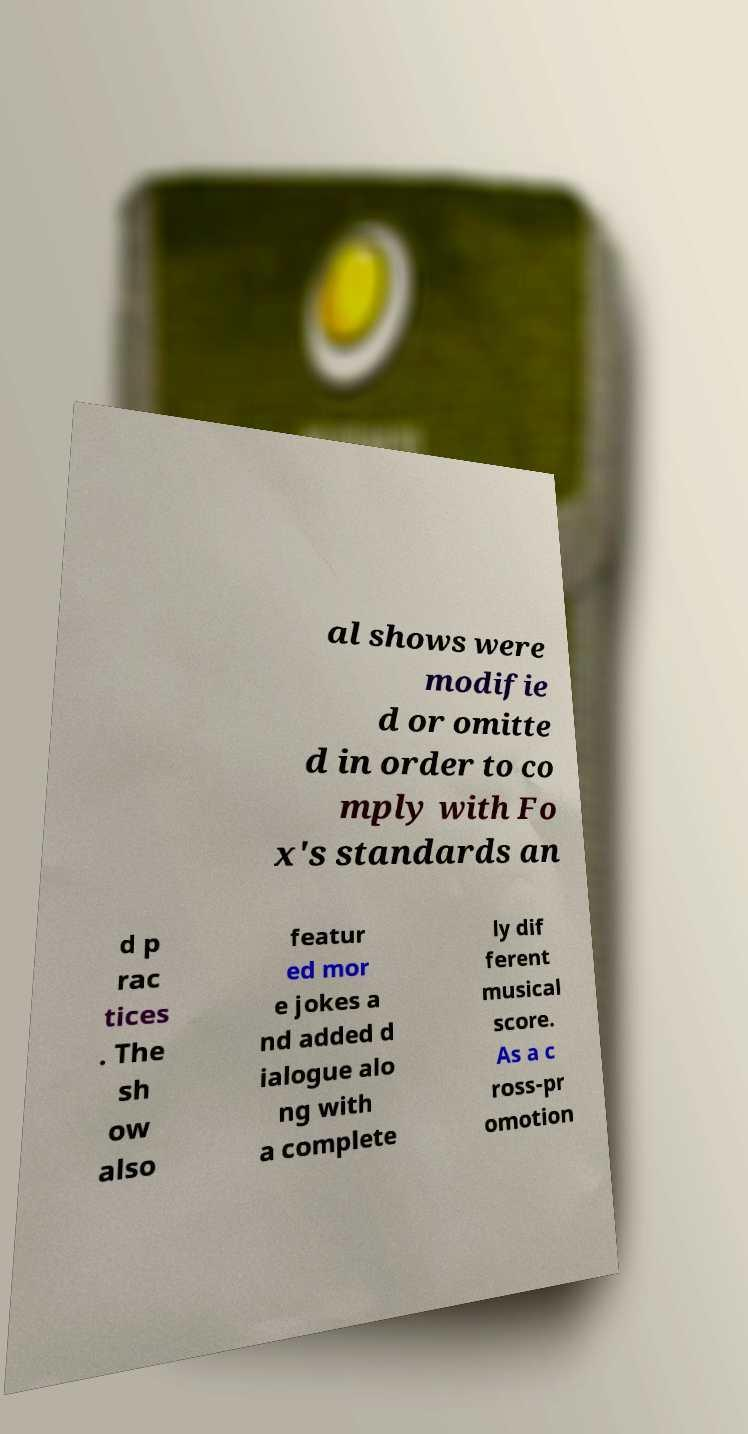Please read and relay the text visible in this image. What does it say? al shows were modifie d or omitte d in order to co mply with Fo x's standards an d p rac tices . The sh ow also featur ed mor e jokes a nd added d ialogue alo ng with a complete ly dif ferent musical score. As a c ross-pr omotion 